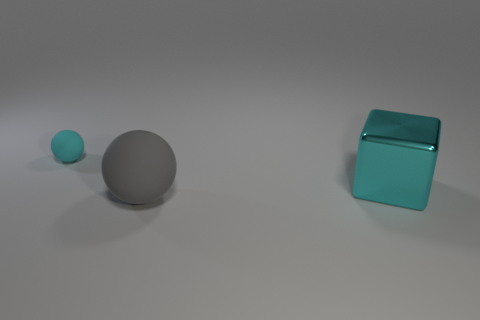How do the shadows in the image inform us about the positioning of the light source? The shadows are cast to the left of the objects, extending diagonally. This suggests the light source is situated to the right and somewhat above the scene. The shadows help us understand the spatial arrangement and give clues to the three-dimensional shape of the objects. 